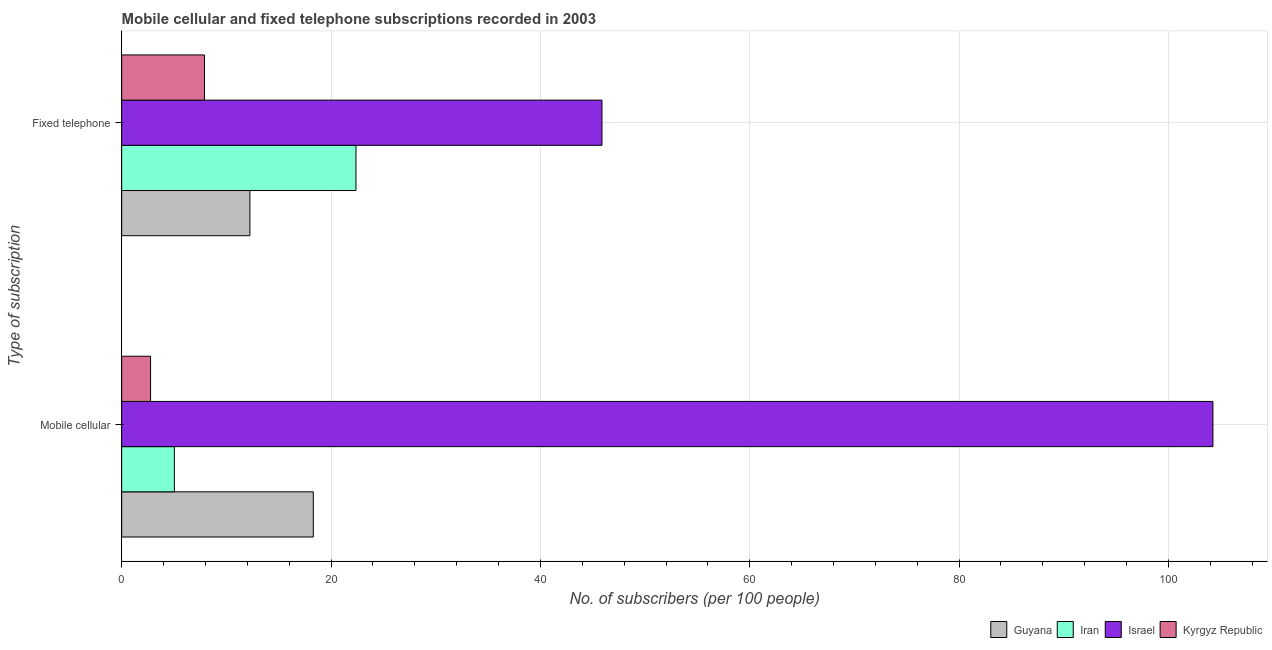How many different coloured bars are there?
Offer a very short reply. 4. How many groups of bars are there?
Your answer should be very brief. 2. Are the number of bars per tick equal to the number of legend labels?
Your answer should be compact. Yes. Are the number of bars on each tick of the Y-axis equal?
Keep it short and to the point. Yes. What is the label of the 2nd group of bars from the top?
Keep it short and to the point. Mobile cellular. What is the number of fixed telephone subscribers in Iran?
Make the answer very short. 22.38. Across all countries, what is the maximum number of fixed telephone subscribers?
Make the answer very short. 45.88. Across all countries, what is the minimum number of mobile cellular subscribers?
Make the answer very short. 2.76. In which country was the number of fixed telephone subscribers minimum?
Provide a succinct answer. Kyrgyz Republic. What is the total number of fixed telephone subscribers in the graph?
Make the answer very short. 88.42. What is the difference between the number of fixed telephone subscribers in Iran and that in Kyrgyz Republic?
Offer a very short reply. 14.47. What is the difference between the number of mobile cellular subscribers in Iran and the number of fixed telephone subscribers in Guyana?
Keep it short and to the point. -7.22. What is the average number of mobile cellular subscribers per country?
Provide a short and direct response. 32.59. What is the difference between the number of fixed telephone subscribers and number of mobile cellular subscribers in Kyrgyz Republic?
Your response must be concise. 5.15. In how many countries, is the number of mobile cellular subscribers greater than 12 ?
Your answer should be compact. 2. What is the ratio of the number of fixed telephone subscribers in Iran to that in Kyrgyz Republic?
Your response must be concise. 2.83. What does the 1st bar from the top in Mobile cellular represents?
Provide a succinct answer. Kyrgyz Republic. What does the 1st bar from the bottom in Fixed telephone represents?
Your answer should be compact. Guyana. How many bars are there?
Offer a terse response. 8. Are the values on the major ticks of X-axis written in scientific E-notation?
Give a very brief answer. No. Does the graph contain any zero values?
Your answer should be compact. No. Does the graph contain grids?
Offer a terse response. Yes. How many legend labels are there?
Provide a short and direct response. 4. What is the title of the graph?
Keep it short and to the point. Mobile cellular and fixed telephone subscriptions recorded in 2003. Does "Israel" appear as one of the legend labels in the graph?
Your answer should be very brief. Yes. What is the label or title of the X-axis?
Provide a succinct answer. No. of subscribers (per 100 people). What is the label or title of the Y-axis?
Offer a very short reply. Type of subscription. What is the No. of subscribers (per 100 people) of Guyana in Mobile cellular?
Your answer should be compact. 18.31. What is the No. of subscribers (per 100 people) of Iran in Mobile cellular?
Make the answer very short. 5.03. What is the No. of subscribers (per 100 people) of Israel in Mobile cellular?
Offer a very short reply. 104.25. What is the No. of subscribers (per 100 people) of Kyrgyz Republic in Mobile cellular?
Offer a terse response. 2.76. What is the No. of subscribers (per 100 people) in Guyana in Fixed telephone?
Provide a short and direct response. 12.25. What is the No. of subscribers (per 100 people) of Iran in Fixed telephone?
Your answer should be compact. 22.38. What is the No. of subscribers (per 100 people) of Israel in Fixed telephone?
Make the answer very short. 45.88. What is the No. of subscribers (per 100 people) of Kyrgyz Republic in Fixed telephone?
Your answer should be compact. 7.91. Across all Type of subscription, what is the maximum No. of subscribers (per 100 people) of Guyana?
Keep it short and to the point. 18.31. Across all Type of subscription, what is the maximum No. of subscribers (per 100 people) in Iran?
Offer a terse response. 22.38. Across all Type of subscription, what is the maximum No. of subscribers (per 100 people) in Israel?
Keep it short and to the point. 104.25. Across all Type of subscription, what is the maximum No. of subscribers (per 100 people) in Kyrgyz Republic?
Provide a succinct answer. 7.91. Across all Type of subscription, what is the minimum No. of subscribers (per 100 people) in Guyana?
Your answer should be very brief. 12.25. Across all Type of subscription, what is the minimum No. of subscribers (per 100 people) of Iran?
Offer a terse response. 5.03. Across all Type of subscription, what is the minimum No. of subscribers (per 100 people) of Israel?
Make the answer very short. 45.88. Across all Type of subscription, what is the minimum No. of subscribers (per 100 people) of Kyrgyz Republic?
Offer a very short reply. 2.76. What is the total No. of subscribers (per 100 people) of Guyana in the graph?
Ensure brevity in your answer.  30.56. What is the total No. of subscribers (per 100 people) of Iran in the graph?
Your answer should be very brief. 27.41. What is the total No. of subscribers (per 100 people) of Israel in the graph?
Your answer should be compact. 150.13. What is the total No. of subscribers (per 100 people) of Kyrgyz Republic in the graph?
Provide a short and direct response. 10.67. What is the difference between the No. of subscribers (per 100 people) of Guyana in Mobile cellular and that in Fixed telephone?
Your response must be concise. 6.05. What is the difference between the No. of subscribers (per 100 people) of Iran in Mobile cellular and that in Fixed telephone?
Make the answer very short. -17.35. What is the difference between the No. of subscribers (per 100 people) in Israel in Mobile cellular and that in Fixed telephone?
Your answer should be very brief. 58.36. What is the difference between the No. of subscribers (per 100 people) of Kyrgyz Republic in Mobile cellular and that in Fixed telephone?
Provide a short and direct response. -5.15. What is the difference between the No. of subscribers (per 100 people) of Guyana in Mobile cellular and the No. of subscribers (per 100 people) of Iran in Fixed telephone?
Make the answer very short. -4.08. What is the difference between the No. of subscribers (per 100 people) in Guyana in Mobile cellular and the No. of subscribers (per 100 people) in Israel in Fixed telephone?
Provide a short and direct response. -27.58. What is the difference between the No. of subscribers (per 100 people) of Guyana in Mobile cellular and the No. of subscribers (per 100 people) of Kyrgyz Republic in Fixed telephone?
Give a very brief answer. 10.4. What is the difference between the No. of subscribers (per 100 people) in Iran in Mobile cellular and the No. of subscribers (per 100 people) in Israel in Fixed telephone?
Your response must be concise. -40.85. What is the difference between the No. of subscribers (per 100 people) of Iran in Mobile cellular and the No. of subscribers (per 100 people) of Kyrgyz Republic in Fixed telephone?
Offer a very short reply. -2.88. What is the difference between the No. of subscribers (per 100 people) of Israel in Mobile cellular and the No. of subscribers (per 100 people) of Kyrgyz Republic in Fixed telephone?
Offer a terse response. 96.34. What is the average No. of subscribers (per 100 people) in Guyana per Type of subscription?
Offer a very short reply. 15.28. What is the average No. of subscribers (per 100 people) of Iran per Type of subscription?
Offer a terse response. 13.71. What is the average No. of subscribers (per 100 people) in Israel per Type of subscription?
Provide a short and direct response. 75.06. What is the average No. of subscribers (per 100 people) in Kyrgyz Republic per Type of subscription?
Make the answer very short. 5.33. What is the difference between the No. of subscribers (per 100 people) of Guyana and No. of subscribers (per 100 people) of Iran in Mobile cellular?
Your answer should be very brief. 13.27. What is the difference between the No. of subscribers (per 100 people) in Guyana and No. of subscribers (per 100 people) in Israel in Mobile cellular?
Offer a very short reply. -85.94. What is the difference between the No. of subscribers (per 100 people) of Guyana and No. of subscribers (per 100 people) of Kyrgyz Republic in Mobile cellular?
Give a very brief answer. 15.55. What is the difference between the No. of subscribers (per 100 people) in Iran and No. of subscribers (per 100 people) in Israel in Mobile cellular?
Your answer should be compact. -99.21. What is the difference between the No. of subscribers (per 100 people) of Iran and No. of subscribers (per 100 people) of Kyrgyz Republic in Mobile cellular?
Provide a succinct answer. 2.27. What is the difference between the No. of subscribers (per 100 people) of Israel and No. of subscribers (per 100 people) of Kyrgyz Republic in Mobile cellular?
Give a very brief answer. 101.49. What is the difference between the No. of subscribers (per 100 people) in Guyana and No. of subscribers (per 100 people) in Iran in Fixed telephone?
Keep it short and to the point. -10.13. What is the difference between the No. of subscribers (per 100 people) in Guyana and No. of subscribers (per 100 people) in Israel in Fixed telephone?
Offer a terse response. -33.63. What is the difference between the No. of subscribers (per 100 people) in Guyana and No. of subscribers (per 100 people) in Kyrgyz Republic in Fixed telephone?
Ensure brevity in your answer.  4.34. What is the difference between the No. of subscribers (per 100 people) of Iran and No. of subscribers (per 100 people) of Israel in Fixed telephone?
Make the answer very short. -23.5. What is the difference between the No. of subscribers (per 100 people) in Iran and No. of subscribers (per 100 people) in Kyrgyz Republic in Fixed telephone?
Your answer should be compact. 14.47. What is the difference between the No. of subscribers (per 100 people) in Israel and No. of subscribers (per 100 people) in Kyrgyz Republic in Fixed telephone?
Your response must be concise. 37.97. What is the ratio of the No. of subscribers (per 100 people) of Guyana in Mobile cellular to that in Fixed telephone?
Give a very brief answer. 1.49. What is the ratio of the No. of subscribers (per 100 people) in Iran in Mobile cellular to that in Fixed telephone?
Keep it short and to the point. 0.22. What is the ratio of the No. of subscribers (per 100 people) of Israel in Mobile cellular to that in Fixed telephone?
Your answer should be compact. 2.27. What is the ratio of the No. of subscribers (per 100 people) in Kyrgyz Republic in Mobile cellular to that in Fixed telephone?
Provide a succinct answer. 0.35. What is the difference between the highest and the second highest No. of subscribers (per 100 people) of Guyana?
Your answer should be very brief. 6.05. What is the difference between the highest and the second highest No. of subscribers (per 100 people) in Iran?
Provide a succinct answer. 17.35. What is the difference between the highest and the second highest No. of subscribers (per 100 people) in Israel?
Give a very brief answer. 58.36. What is the difference between the highest and the second highest No. of subscribers (per 100 people) of Kyrgyz Republic?
Make the answer very short. 5.15. What is the difference between the highest and the lowest No. of subscribers (per 100 people) of Guyana?
Your answer should be very brief. 6.05. What is the difference between the highest and the lowest No. of subscribers (per 100 people) of Iran?
Your answer should be very brief. 17.35. What is the difference between the highest and the lowest No. of subscribers (per 100 people) in Israel?
Ensure brevity in your answer.  58.36. What is the difference between the highest and the lowest No. of subscribers (per 100 people) in Kyrgyz Republic?
Make the answer very short. 5.15. 